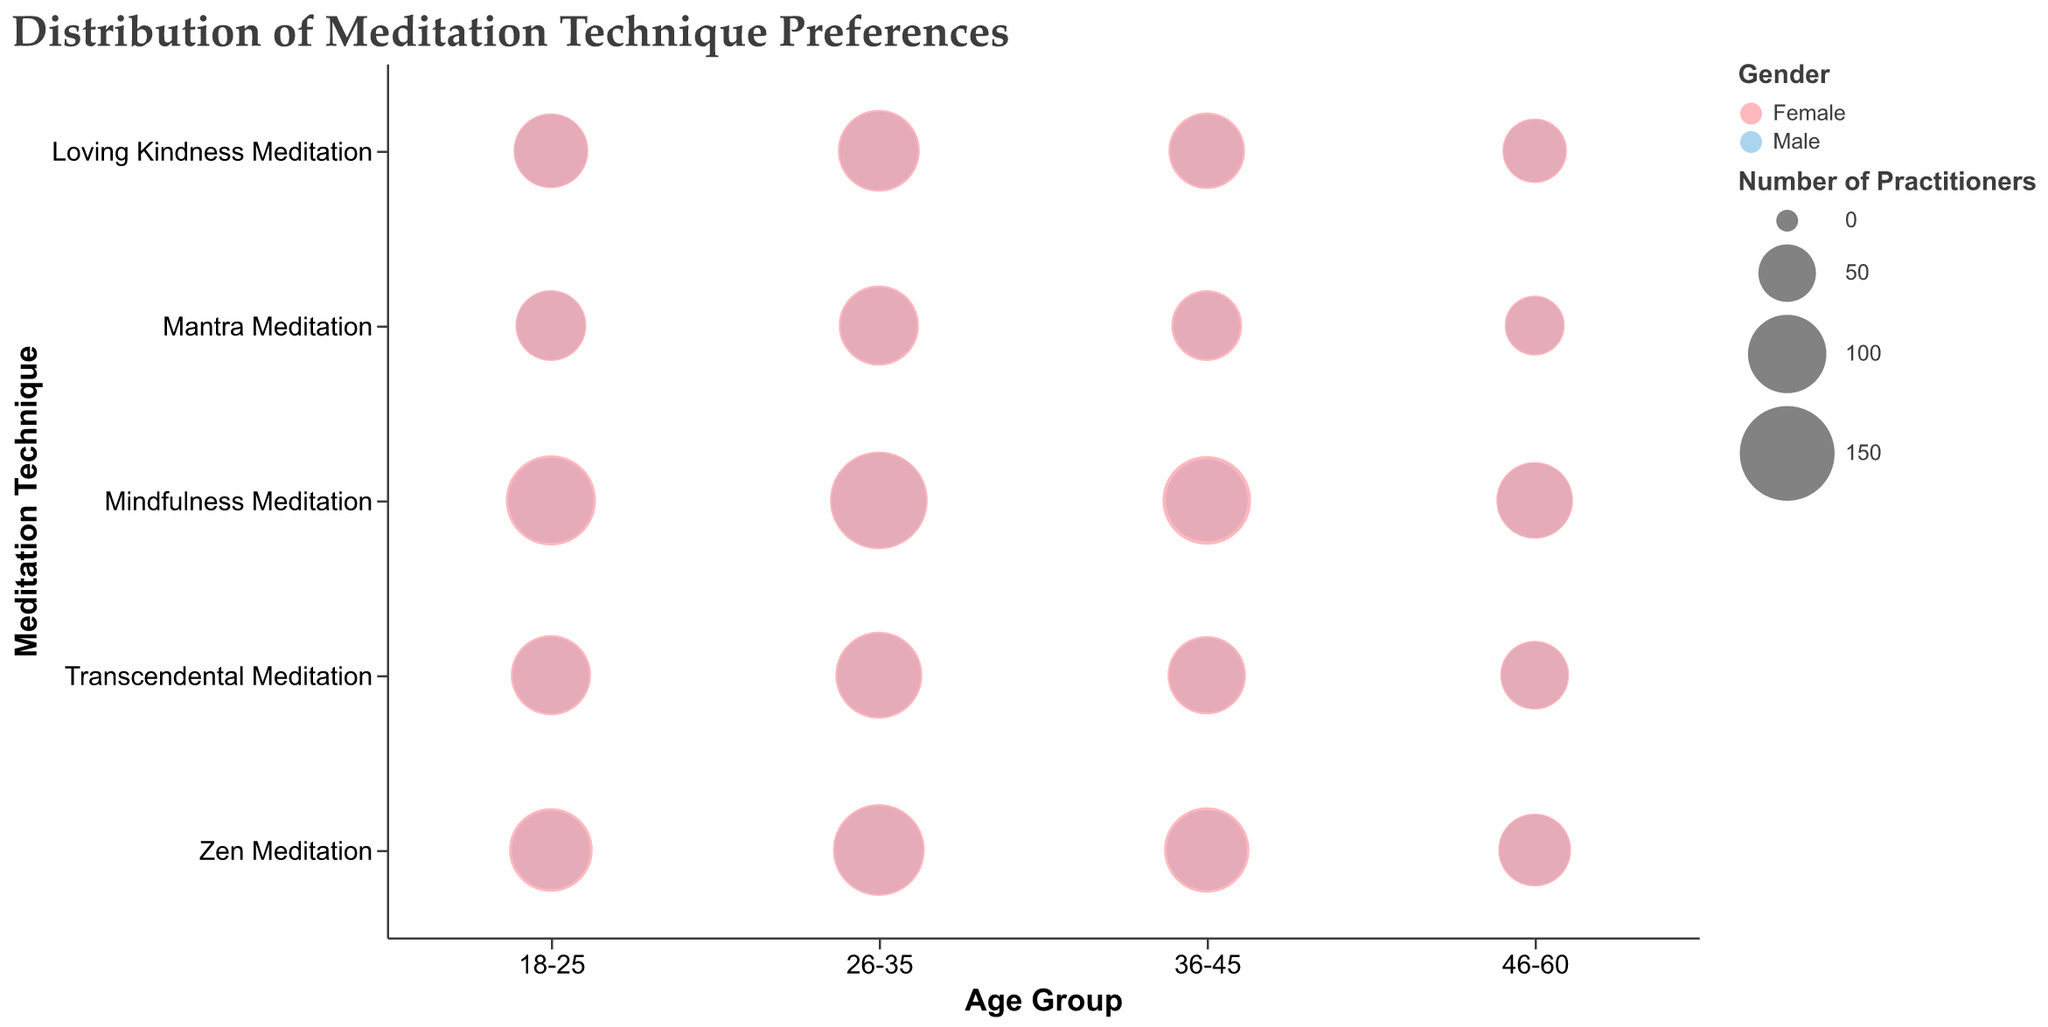What is the title of the chart? The title of the chart is written at the top and provides an overview of what the chart is about.
Answer: Distribution of Meditation Technique Preferences Which meditation technique has the highest number of practitioners among 26-35 year old females? To find this, look at the bubbles corresponding to 26-35 year old females in the y-axis and compare their sizes. Mindfulness Meditation has the largest bubble.
Answer: Mindfulness Meditation Is there a noticeable difference in the number of male practitioners between 18-25 and 46-60 age groups for Zen Meditation? Compare the sizes of the bubbles for Zen Meditation between these two age groups for males. The bubble for 18-25 males is noticeably larger than for 46-60 males.
Answer: Yes Which age group shows the highest preference for Mindfulness Meditation among females? Look at the y-axis for Mindfulness Meditation and compare the sizes of the bubbles across different age groups for females. The 26-35 age group has the largest bubble.
Answer: 26-35 How many females prefer Loving Kindness Meditation in the 46-60 age group combined with those preferring it in the 36-45 age group? Add the number of females practicing Loving Kindness Meditation in both age groups: 65 (46-60) + 95 (36-45).
Answer: 160 Compare the number of male practitioners of Mantra Meditation in the 18-25 age group with those in the 46-60 age group. Which is greater? Look at the bubbles for Mantra Meditation in the 18-25 and 46-60 age groups for males and compare their sizes. The bubble for 18-25 is larger.
Answer: 18-25 What is the total number of male practitioners of Transcendental Meditation across all age groups? Sum the counts of male practitioners of Transcendental Meditation across all age groups: 95 (18-25) + 115 (26-35) + 90 (36-45) + 70 (46-60).
Answer: 370 Which meditation technique has the least number of female practitioners in the 18-25 age group? Compare the sizes of the female bubbles for each meditation technique in the 18-25 age group. Loving Kindness Meditation has the smallest bubble.
Answer: Loving Kindness Meditation Are there more female practitioners of Zen Meditation or Mantra Meditation in the 26-35 age group? Compare the sizes of the bubbles for 26-35 year old females in Zen Meditation and Mantra Meditation. The Zen Meditation bubble is larger.
Answer: Zen Meditation What's the difference in the number of female practitioners of Mindfulness Meditation and Transcendental Meditation in the 36-45 age group? Subtract the count of Transcendental Meditation practitioners from the count of Mindfulness Meditation practitioners for females in the 36-45 age group: 130 - 100.
Answer: 30 